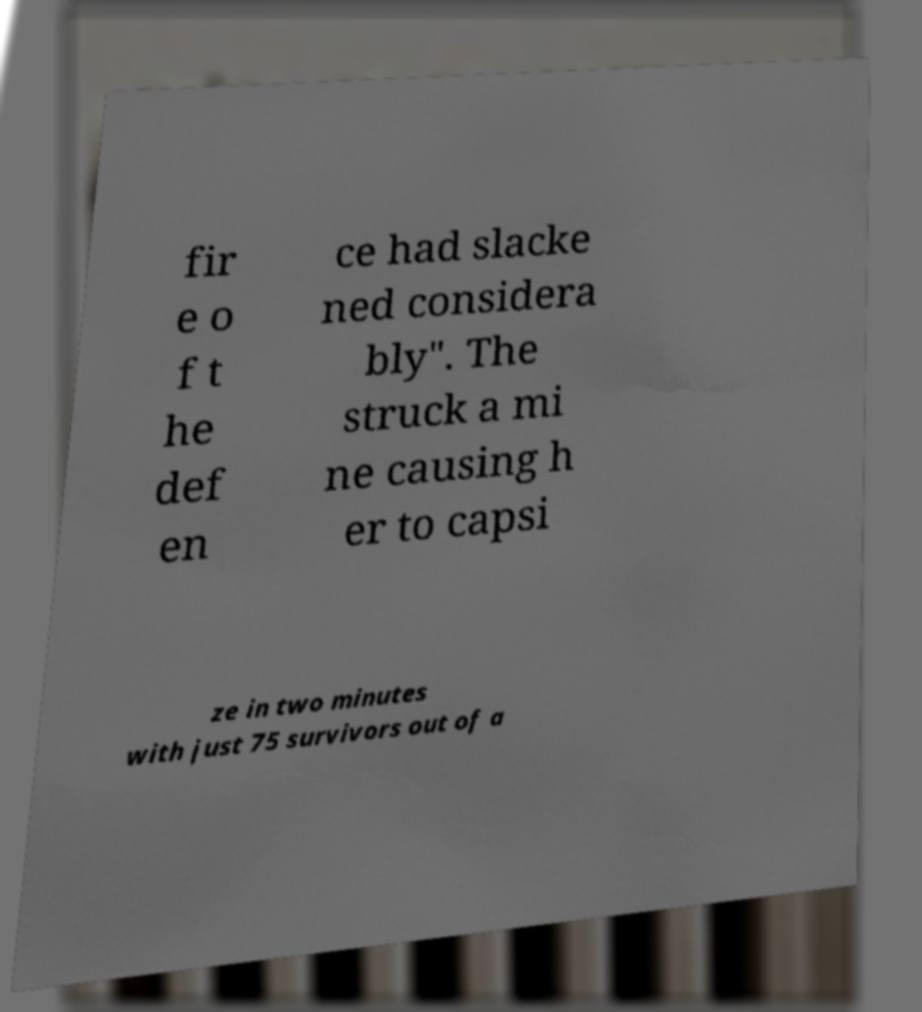For documentation purposes, I need the text within this image transcribed. Could you provide that? fir e o f t he def en ce had slacke ned considera bly". The struck a mi ne causing h er to capsi ze in two minutes with just 75 survivors out of a 